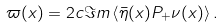Convert formula to latex. <formula><loc_0><loc_0><loc_500><loc_500>\varpi ( x ) = 2 c { \Im m } \left < \bar { \eta } ( x ) P _ { + } \nu ( x ) \right > .</formula> 